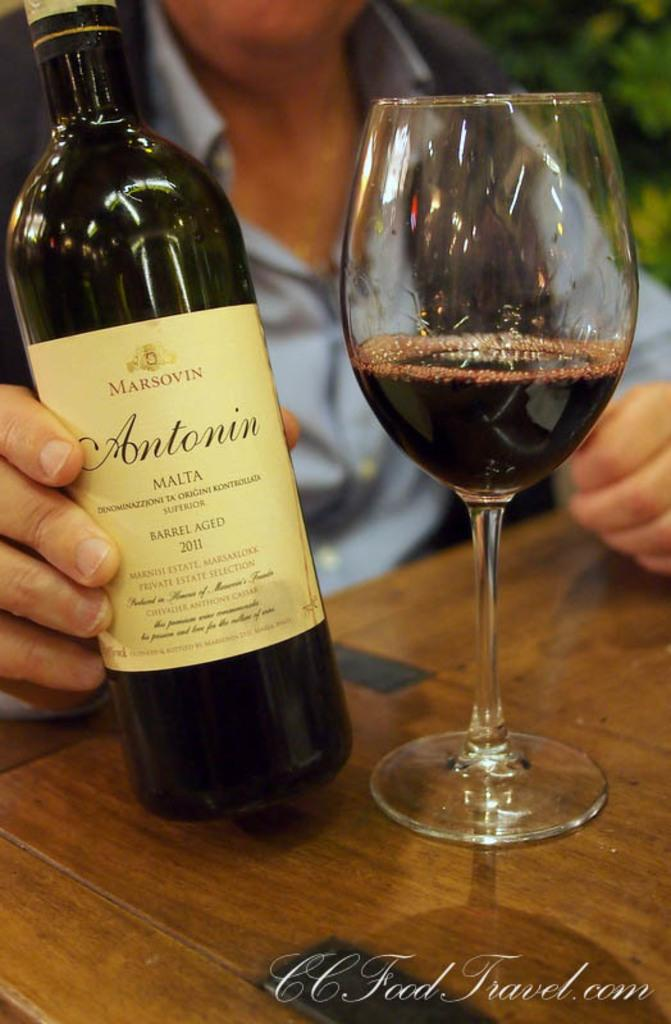<image>
Share a concise interpretation of the image provided. An Antonin bottle of barrel aged wine from 2011. 